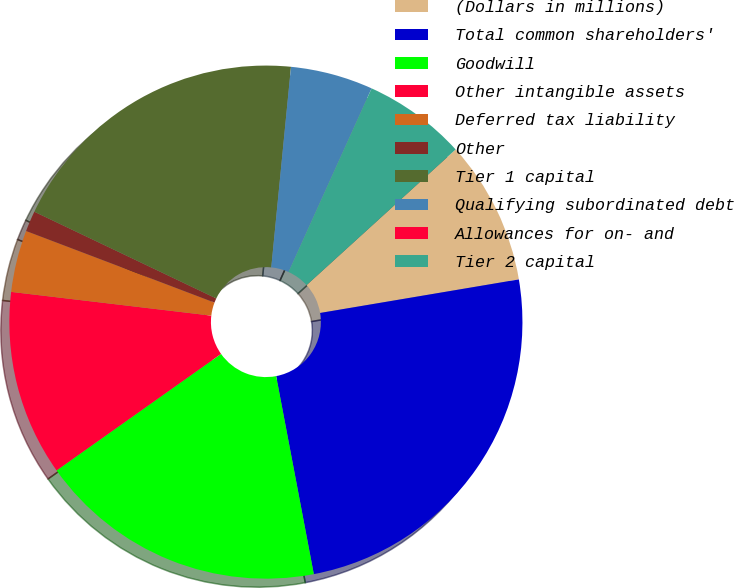Convert chart. <chart><loc_0><loc_0><loc_500><loc_500><pie_chart><fcel>(Dollars in millions)<fcel>Total common shareholders'<fcel>Goodwill<fcel>Other intangible assets<fcel>Deferred tax liability<fcel>Other<fcel>Tier 1 capital<fcel>Qualifying subordinated debt<fcel>Allowances for on- and<fcel>Tier 2 capital<nl><fcel>9.09%<fcel>24.67%<fcel>18.18%<fcel>11.69%<fcel>3.9%<fcel>1.3%<fcel>19.48%<fcel>5.2%<fcel>0.0%<fcel>6.49%<nl></chart> 